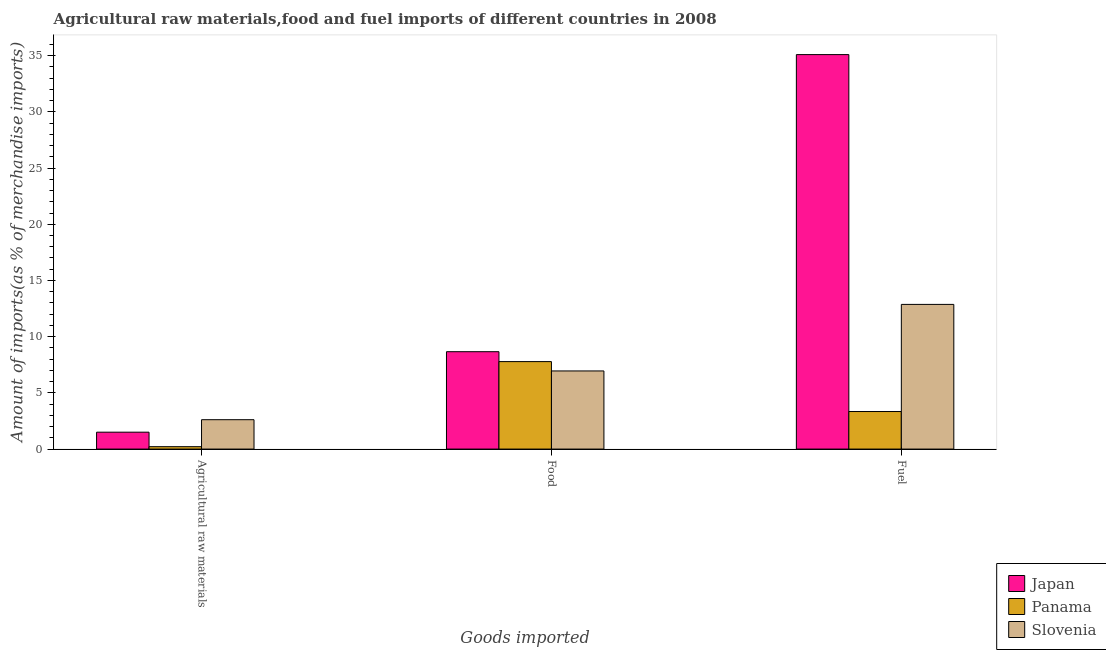How many groups of bars are there?
Offer a terse response. 3. Are the number of bars per tick equal to the number of legend labels?
Offer a very short reply. Yes. Are the number of bars on each tick of the X-axis equal?
Your answer should be compact. Yes. How many bars are there on the 2nd tick from the left?
Provide a succinct answer. 3. What is the label of the 1st group of bars from the left?
Provide a succinct answer. Agricultural raw materials. What is the percentage of fuel imports in Slovenia?
Offer a terse response. 12.87. Across all countries, what is the maximum percentage of fuel imports?
Provide a short and direct response. 35.1. Across all countries, what is the minimum percentage of raw materials imports?
Your answer should be very brief. 0.21. In which country was the percentage of fuel imports maximum?
Offer a terse response. Japan. In which country was the percentage of raw materials imports minimum?
Make the answer very short. Panama. What is the total percentage of food imports in the graph?
Your answer should be very brief. 23.4. What is the difference between the percentage of food imports in Panama and that in Japan?
Make the answer very short. -0.88. What is the difference between the percentage of raw materials imports in Panama and the percentage of food imports in Japan?
Provide a short and direct response. -8.45. What is the average percentage of fuel imports per country?
Ensure brevity in your answer.  17.1. What is the difference between the percentage of raw materials imports and percentage of food imports in Panama?
Keep it short and to the point. -7.57. In how many countries, is the percentage of raw materials imports greater than 6 %?
Offer a terse response. 0. What is the ratio of the percentage of food imports in Japan to that in Slovenia?
Offer a terse response. 1.25. Is the difference between the percentage of raw materials imports in Panama and Slovenia greater than the difference between the percentage of fuel imports in Panama and Slovenia?
Keep it short and to the point. Yes. What is the difference between the highest and the second highest percentage of raw materials imports?
Give a very brief answer. 1.11. What is the difference between the highest and the lowest percentage of fuel imports?
Offer a very short reply. 31.75. Is the sum of the percentage of raw materials imports in Slovenia and Japan greater than the maximum percentage of food imports across all countries?
Ensure brevity in your answer.  No. What does the 1st bar from the left in Fuel represents?
Provide a short and direct response. Japan. What does the 1st bar from the right in Agricultural raw materials represents?
Offer a very short reply. Slovenia. Are the values on the major ticks of Y-axis written in scientific E-notation?
Make the answer very short. No. Does the graph contain any zero values?
Give a very brief answer. No. Does the graph contain grids?
Provide a succinct answer. No. Where does the legend appear in the graph?
Offer a very short reply. Bottom right. How are the legend labels stacked?
Your answer should be compact. Vertical. What is the title of the graph?
Keep it short and to the point. Agricultural raw materials,food and fuel imports of different countries in 2008. Does "West Bank and Gaza" appear as one of the legend labels in the graph?
Ensure brevity in your answer.  No. What is the label or title of the X-axis?
Make the answer very short. Goods imported. What is the label or title of the Y-axis?
Your answer should be very brief. Amount of imports(as % of merchandise imports). What is the Amount of imports(as % of merchandise imports) of Japan in Agricultural raw materials?
Provide a short and direct response. 1.5. What is the Amount of imports(as % of merchandise imports) of Panama in Agricultural raw materials?
Your response must be concise. 0.21. What is the Amount of imports(as % of merchandise imports) of Slovenia in Agricultural raw materials?
Offer a terse response. 2.61. What is the Amount of imports(as % of merchandise imports) of Japan in Food?
Make the answer very short. 8.66. What is the Amount of imports(as % of merchandise imports) of Panama in Food?
Offer a terse response. 7.78. What is the Amount of imports(as % of merchandise imports) of Slovenia in Food?
Provide a short and direct response. 6.95. What is the Amount of imports(as % of merchandise imports) in Japan in Fuel?
Ensure brevity in your answer.  35.1. What is the Amount of imports(as % of merchandise imports) in Panama in Fuel?
Provide a succinct answer. 3.34. What is the Amount of imports(as % of merchandise imports) in Slovenia in Fuel?
Offer a very short reply. 12.87. Across all Goods imported, what is the maximum Amount of imports(as % of merchandise imports) of Japan?
Ensure brevity in your answer.  35.1. Across all Goods imported, what is the maximum Amount of imports(as % of merchandise imports) in Panama?
Your response must be concise. 7.78. Across all Goods imported, what is the maximum Amount of imports(as % of merchandise imports) in Slovenia?
Your response must be concise. 12.87. Across all Goods imported, what is the minimum Amount of imports(as % of merchandise imports) of Japan?
Provide a succinct answer. 1.5. Across all Goods imported, what is the minimum Amount of imports(as % of merchandise imports) in Panama?
Ensure brevity in your answer.  0.21. Across all Goods imported, what is the minimum Amount of imports(as % of merchandise imports) of Slovenia?
Provide a succinct answer. 2.61. What is the total Amount of imports(as % of merchandise imports) of Japan in the graph?
Keep it short and to the point. 45.26. What is the total Amount of imports(as % of merchandise imports) of Panama in the graph?
Keep it short and to the point. 11.34. What is the total Amount of imports(as % of merchandise imports) in Slovenia in the graph?
Make the answer very short. 22.44. What is the difference between the Amount of imports(as % of merchandise imports) of Japan in Agricultural raw materials and that in Food?
Keep it short and to the point. -7.16. What is the difference between the Amount of imports(as % of merchandise imports) in Panama in Agricultural raw materials and that in Food?
Provide a succinct answer. -7.57. What is the difference between the Amount of imports(as % of merchandise imports) in Slovenia in Agricultural raw materials and that in Food?
Keep it short and to the point. -4.34. What is the difference between the Amount of imports(as % of merchandise imports) of Japan in Agricultural raw materials and that in Fuel?
Your answer should be compact. -33.59. What is the difference between the Amount of imports(as % of merchandise imports) of Panama in Agricultural raw materials and that in Fuel?
Give a very brief answer. -3.13. What is the difference between the Amount of imports(as % of merchandise imports) of Slovenia in Agricultural raw materials and that in Fuel?
Ensure brevity in your answer.  -10.26. What is the difference between the Amount of imports(as % of merchandise imports) of Japan in Food and that in Fuel?
Your answer should be compact. -26.43. What is the difference between the Amount of imports(as % of merchandise imports) of Panama in Food and that in Fuel?
Provide a succinct answer. 4.44. What is the difference between the Amount of imports(as % of merchandise imports) in Slovenia in Food and that in Fuel?
Keep it short and to the point. -5.92. What is the difference between the Amount of imports(as % of merchandise imports) of Japan in Agricultural raw materials and the Amount of imports(as % of merchandise imports) of Panama in Food?
Keep it short and to the point. -6.28. What is the difference between the Amount of imports(as % of merchandise imports) in Japan in Agricultural raw materials and the Amount of imports(as % of merchandise imports) in Slovenia in Food?
Your answer should be very brief. -5.45. What is the difference between the Amount of imports(as % of merchandise imports) of Panama in Agricultural raw materials and the Amount of imports(as % of merchandise imports) of Slovenia in Food?
Provide a succinct answer. -6.74. What is the difference between the Amount of imports(as % of merchandise imports) in Japan in Agricultural raw materials and the Amount of imports(as % of merchandise imports) in Panama in Fuel?
Offer a very short reply. -1.84. What is the difference between the Amount of imports(as % of merchandise imports) of Japan in Agricultural raw materials and the Amount of imports(as % of merchandise imports) of Slovenia in Fuel?
Ensure brevity in your answer.  -11.37. What is the difference between the Amount of imports(as % of merchandise imports) of Panama in Agricultural raw materials and the Amount of imports(as % of merchandise imports) of Slovenia in Fuel?
Offer a terse response. -12.66. What is the difference between the Amount of imports(as % of merchandise imports) in Japan in Food and the Amount of imports(as % of merchandise imports) in Panama in Fuel?
Your response must be concise. 5.32. What is the difference between the Amount of imports(as % of merchandise imports) of Japan in Food and the Amount of imports(as % of merchandise imports) of Slovenia in Fuel?
Your answer should be very brief. -4.21. What is the difference between the Amount of imports(as % of merchandise imports) of Panama in Food and the Amount of imports(as % of merchandise imports) of Slovenia in Fuel?
Provide a succinct answer. -5.09. What is the average Amount of imports(as % of merchandise imports) of Japan per Goods imported?
Provide a short and direct response. 15.09. What is the average Amount of imports(as % of merchandise imports) of Panama per Goods imported?
Provide a succinct answer. 3.78. What is the average Amount of imports(as % of merchandise imports) in Slovenia per Goods imported?
Keep it short and to the point. 7.48. What is the difference between the Amount of imports(as % of merchandise imports) of Japan and Amount of imports(as % of merchandise imports) of Panama in Agricultural raw materials?
Provide a succinct answer. 1.29. What is the difference between the Amount of imports(as % of merchandise imports) in Japan and Amount of imports(as % of merchandise imports) in Slovenia in Agricultural raw materials?
Offer a terse response. -1.11. What is the difference between the Amount of imports(as % of merchandise imports) in Panama and Amount of imports(as % of merchandise imports) in Slovenia in Agricultural raw materials?
Offer a very short reply. -2.4. What is the difference between the Amount of imports(as % of merchandise imports) in Japan and Amount of imports(as % of merchandise imports) in Panama in Food?
Make the answer very short. 0.88. What is the difference between the Amount of imports(as % of merchandise imports) of Japan and Amount of imports(as % of merchandise imports) of Slovenia in Food?
Keep it short and to the point. 1.71. What is the difference between the Amount of imports(as % of merchandise imports) in Panama and Amount of imports(as % of merchandise imports) in Slovenia in Food?
Provide a succinct answer. 0.83. What is the difference between the Amount of imports(as % of merchandise imports) in Japan and Amount of imports(as % of merchandise imports) in Panama in Fuel?
Your answer should be very brief. 31.75. What is the difference between the Amount of imports(as % of merchandise imports) of Japan and Amount of imports(as % of merchandise imports) of Slovenia in Fuel?
Offer a very short reply. 22.22. What is the difference between the Amount of imports(as % of merchandise imports) of Panama and Amount of imports(as % of merchandise imports) of Slovenia in Fuel?
Give a very brief answer. -9.53. What is the ratio of the Amount of imports(as % of merchandise imports) of Japan in Agricultural raw materials to that in Food?
Give a very brief answer. 0.17. What is the ratio of the Amount of imports(as % of merchandise imports) in Panama in Agricultural raw materials to that in Food?
Your answer should be very brief. 0.03. What is the ratio of the Amount of imports(as % of merchandise imports) of Slovenia in Agricultural raw materials to that in Food?
Make the answer very short. 0.38. What is the ratio of the Amount of imports(as % of merchandise imports) of Japan in Agricultural raw materials to that in Fuel?
Make the answer very short. 0.04. What is the ratio of the Amount of imports(as % of merchandise imports) in Panama in Agricultural raw materials to that in Fuel?
Your answer should be compact. 0.06. What is the ratio of the Amount of imports(as % of merchandise imports) of Slovenia in Agricultural raw materials to that in Fuel?
Make the answer very short. 0.2. What is the ratio of the Amount of imports(as % of merchandise imports) in Japan in Food to that in Fuel?
Your answer should be compact. 0.25. What is the ratio of the Amount of imports(as % of merchandise imports) in Panama in Food to that in Fuel?
Provide a short and direct response. 2.33. What is the ratio of the Amount of imports(as % of merchandise imports) in Slovenia in Food to that in Fuel?
Offer a very short reply. 0.54. What is the difference between the highest and the second highest Amount of imports(as % of merchandise imports) in Japan?
Give a very brief answer. 26.43. What is the difference between the highest and the second highest Amount of imports(as % of merchandise imports) of Panama?
Give a very brief answer. 4.44. What is the difference between the highest and the second highest Amount of imports(as % of merchandise imports) in Slovenia?
Ensure brevity in your answer.  5.92. What is the difference between the highest and the lowest Amount of imports(as % of merchandise imports) of Japan?
Keep it short and to the point. 33.59. What is the difference between the highest and the lowest Amount of imports(as % of merchandise imports) in Panama?
Provide a succinct answer. 7.57. What is the difference between the highest and the lowest Amount of imports(as % of merchandise imports) in Slovenia?
Your response must be concise. 10.26. 